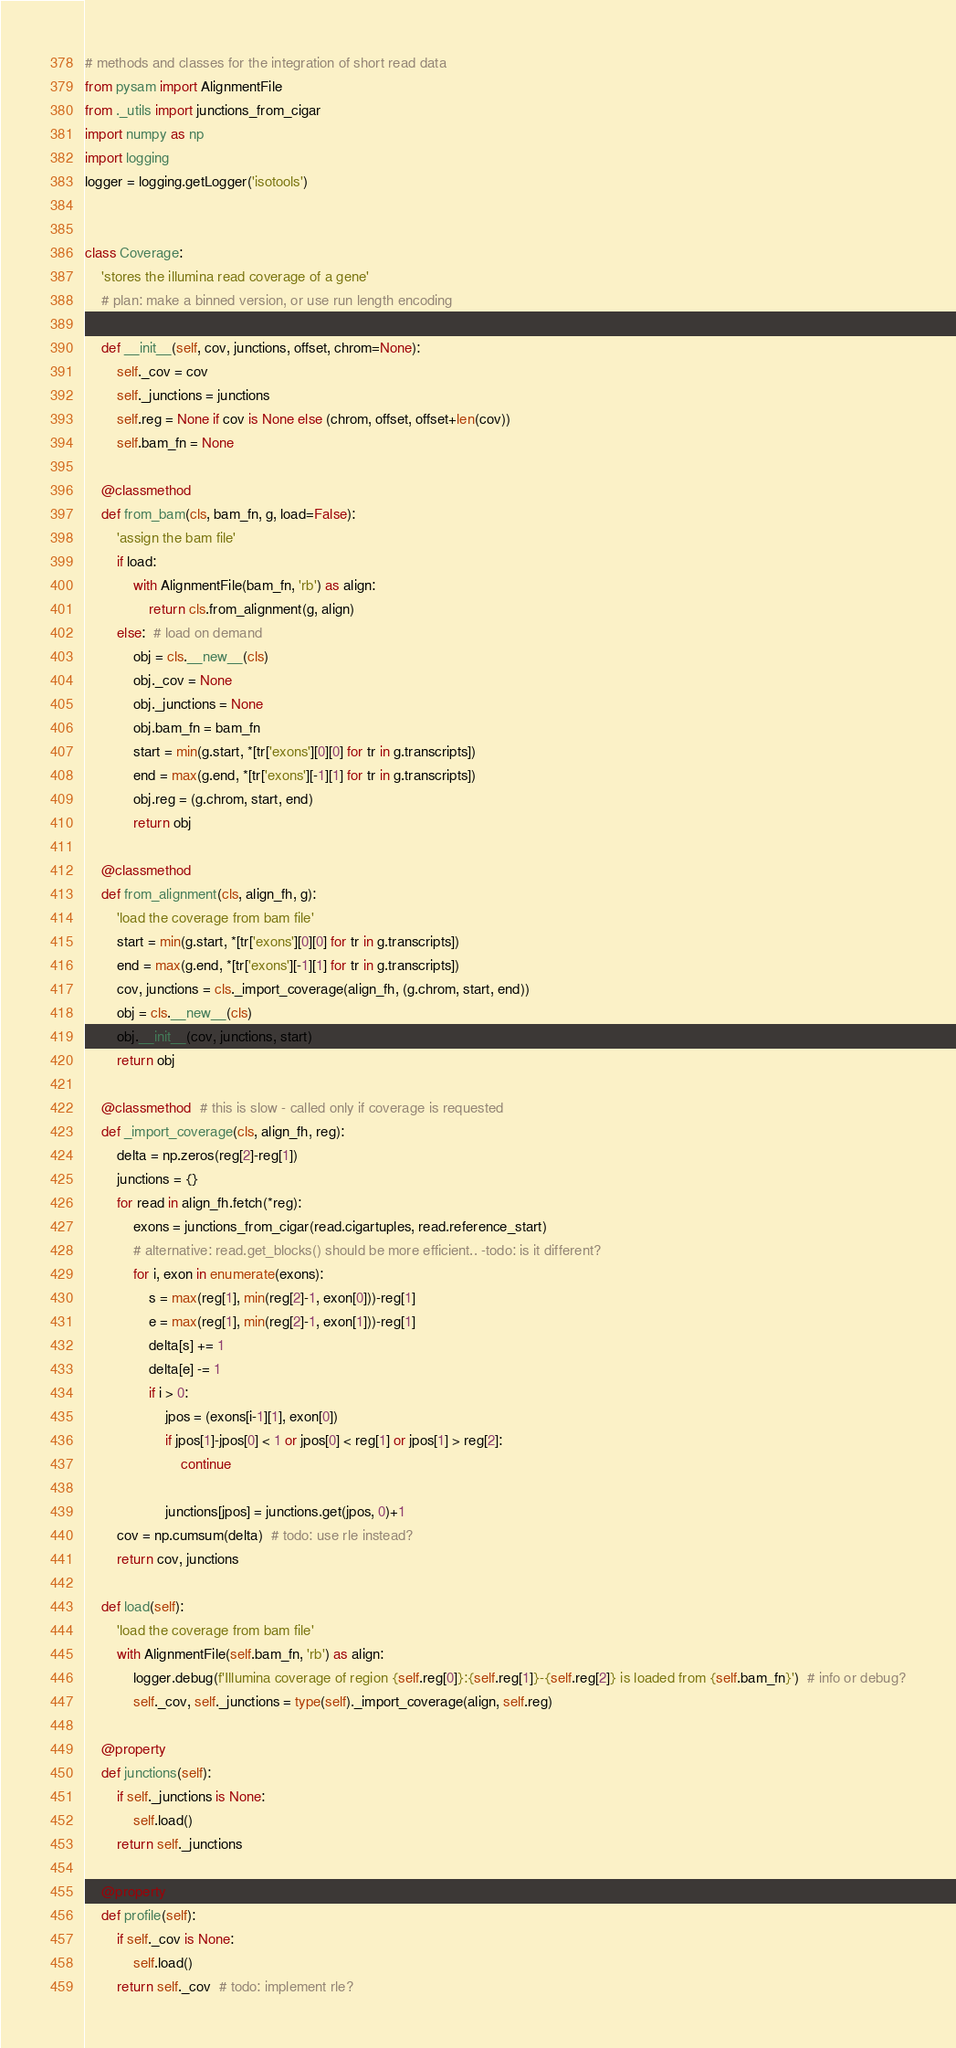Convert code to text. <code><loc_0><loc_0><loc_500><loc_500><_Python_># methods and classes for the integration of short read data
from pysam import AlignmentFile
from ._utils import junctions_from_cigar
import numpy as np
import logging
logger = logging.getLogger('isotools')


class Coverage:
    'stores the illumina read coverage of a gene'
    # plan: make a binned version, or use run length encoding

    def __init__(self, cov, junctions, offset, chrom=None):
        self._cov = cov
        self._junctions = junctions
        self.reg = None if cov is None else (chrom, offset, offset+len(cov))
        self.bam_fn = None

    @classmethod
    def from_bam(cls, bam_fn, g, load=False):
        'assign the bam file'
        if load:
            with AlignmentFile(bam_fn, 'rb') as align:
                return cls.from_alignment(g, align)
        else:  # load on demand
            obj = cls.__new__(cls)
            obj._cov = None
            obj._junctions = None
            obj.bam_fn = bam_fn
            start = min(g.start, *[tr['exons'][0][0] for tr in g.transcripts])
            end = max(g.end, *[tr['exons'][-1][1] for tr in g.transcripts])
            obj.reg = (g.chrom, start, end)
            return obj

    @classmethod
    def from_alignment(cls, align_fh, g):
        'load the coverage from bam file'
        start = min(g.start, *[tr['exons'][0][0] for tr in g.transcripts])
        end = max(g.end, *[tr['exons'][-1][1] for tr in g.transcripts])
        cov, junctions = cls._import_coverage(align_fh, (g.chrom, start, end))
        obj = cls.__new__(cls)
        obj.__init__(cov, junctions, start)
        return obj

    @classmethod  # this is slow - called only if coverage is requested
    def _import_coverage(cls, align_fh, reg):
        delta = np.zeros(reg[2]-reg[1])
        junctions = {}
        for read in align_fh.fetch(*reg):
            exons = junctions_from_cigar(read.cigartuples, read.reference_start)
            # alternative: read.get_blocks() should be more efficient.. -todo: is it different?
            for i, exon in enumerate(exons):
                s = max(reg[1], min(reg[2]-1, exon[0]))-reg[1]
                e = max(reg[1], min(reg[2]-1, exon[1]))-reg[1]
                delta[s] += 1
                delta[e] -= 1
                if i > 0:
                    jpos = (exons[i-1][1], exon[0])
                    if jpos[1]-jpos[0] < 1 or jpos[0] < reg[1] or jpos[1] > reg[2]:
                        continue

                    junctions[jpos] = junctions.get(jpos, 0)+1
        cov = np.cumsum(delta)  # todo: use rle instead?
        return cov, junctions

    def load(self):
        'load the coverage from bam file'
        with AlignmentFile(self.bam_fn, 'rb') as align:
            logger.debug(f'Illumina coverage of region {self.reg[0]}:{self.reg[1]}-{self.reg[2]} is loaded from {self.bam_fn}')  # info or debug?
            self._cov, self._junctions = type(self)._import_coverage(align, self.reg)

    @property
    def junctions(self):
        if self._junctions is None:
            self.load()
        return self._junctions

    @property
    def profile(self):
        if self._cov is None:
            self.load()
        return self._cov  # todo: implement rle?
</code> 